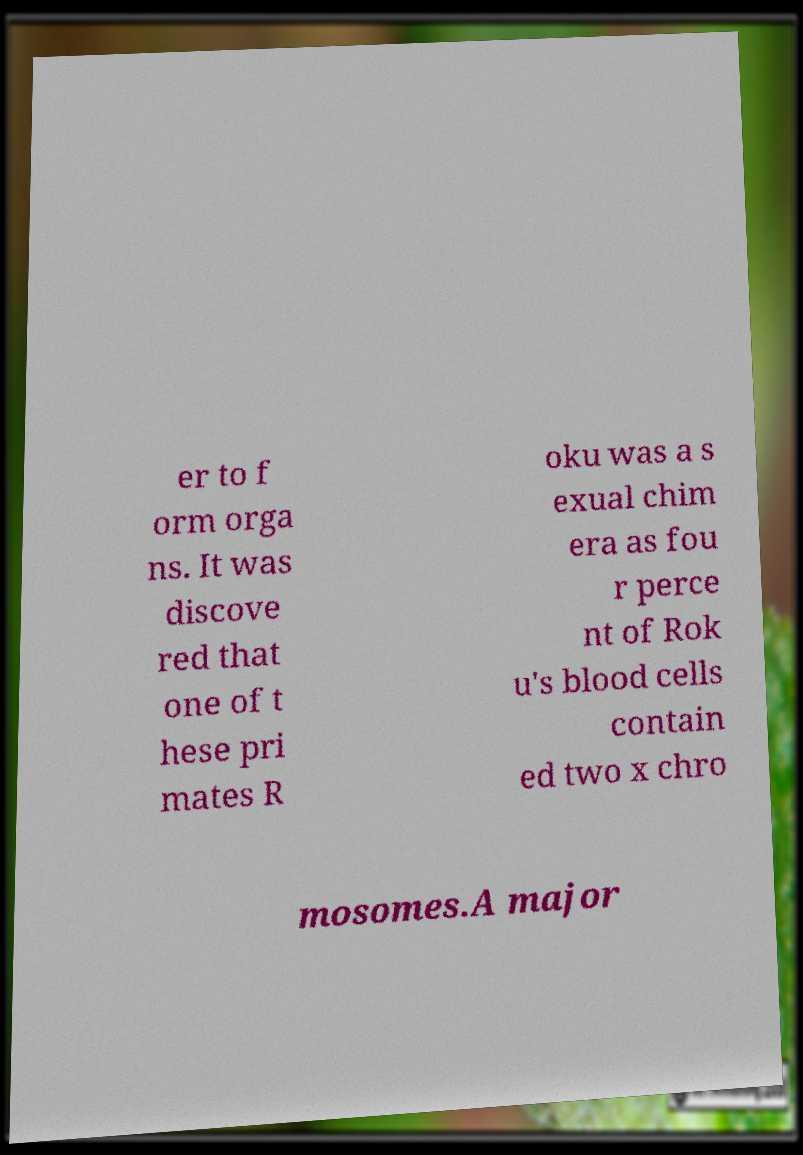What messages or text are displayed in this image? I need them in a readable, typed format. er to f orm orga ns. It was discove red that one of t hese pri mates R oku was a s exual chim era as fou r perce nt of Rok u's blood cells contain ed two x chro mosomes.A major 